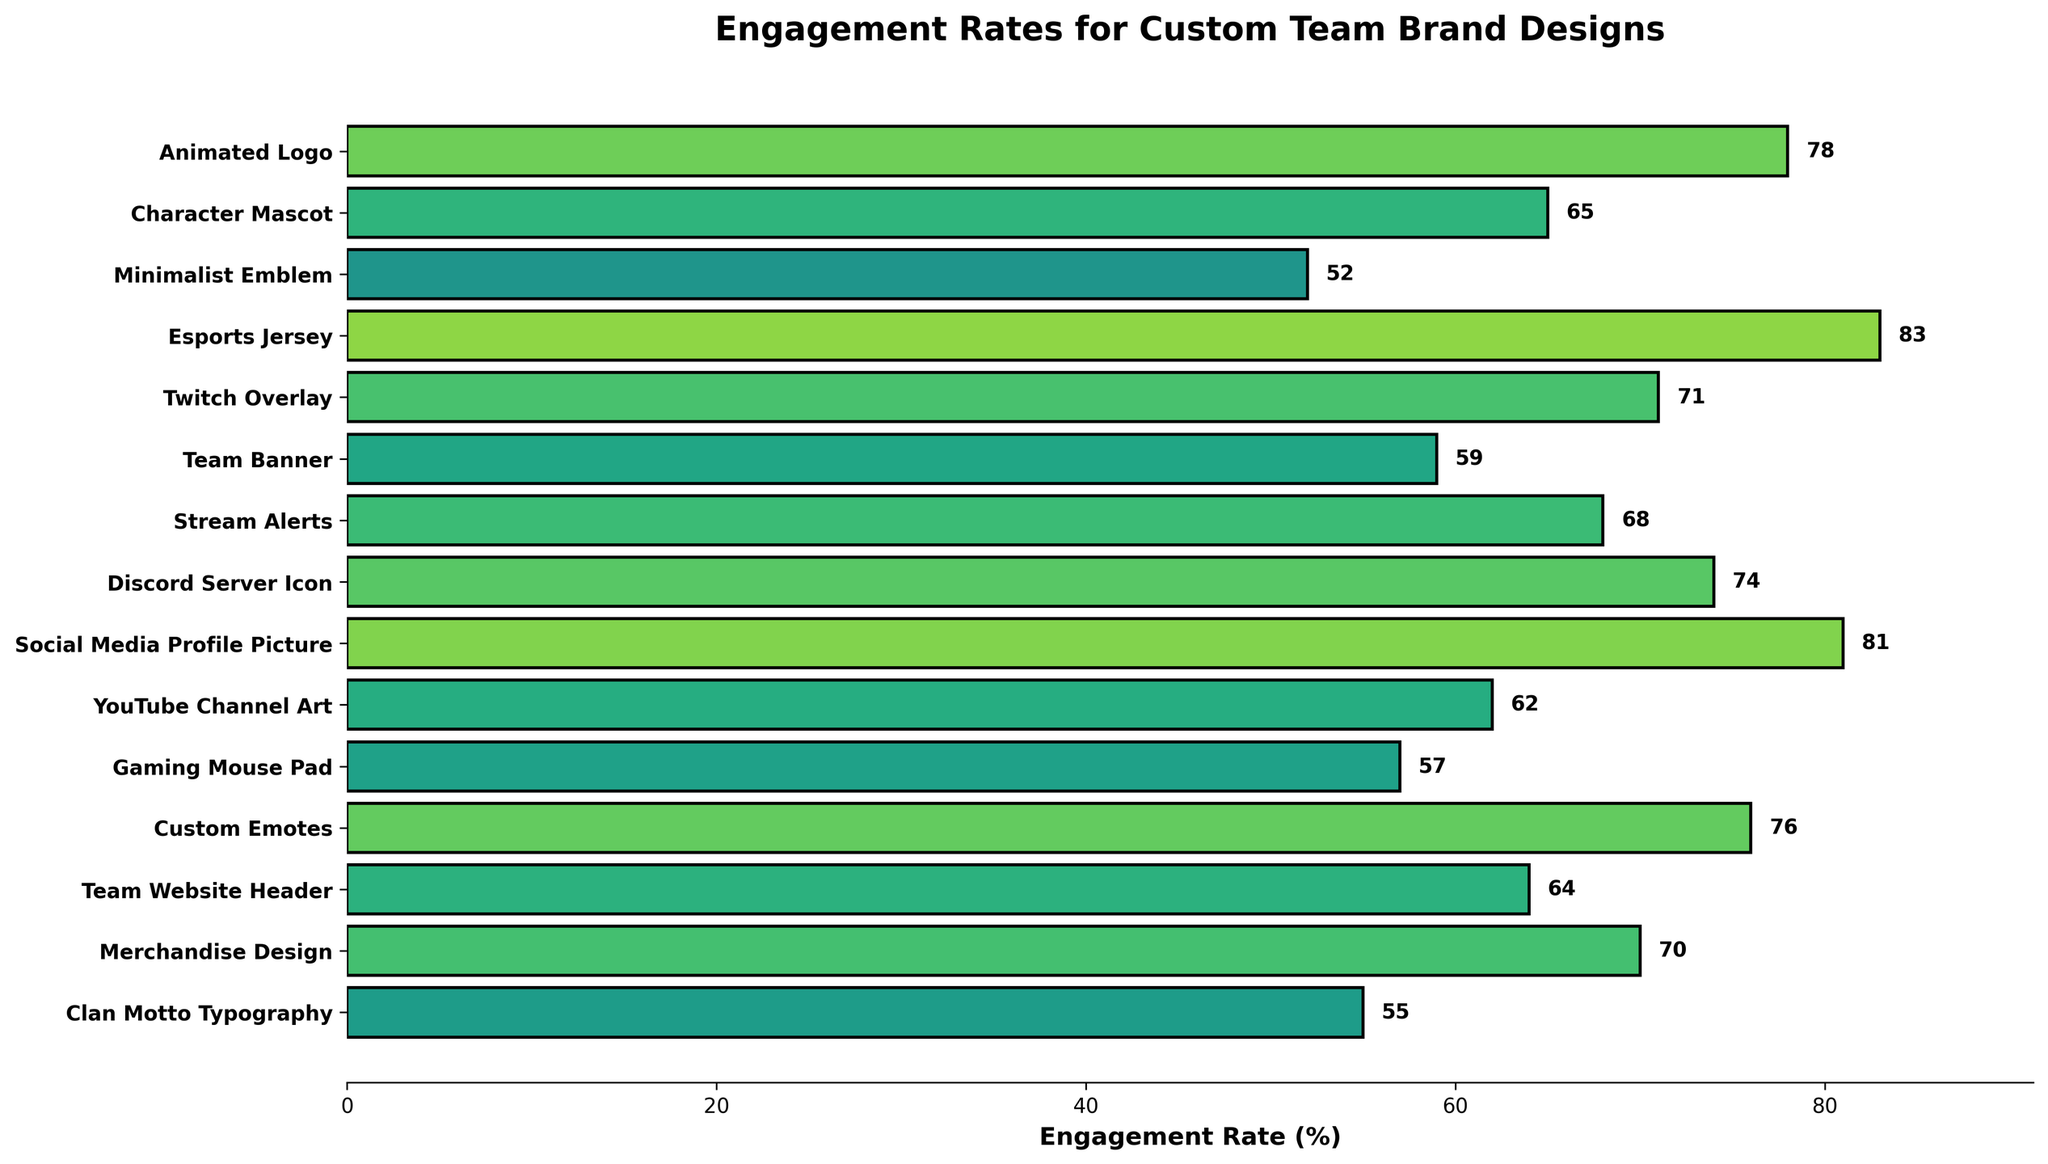Which design type has the highest engagement rate? The bar for Esports Jersey is the longest compared to others, reaching the highest engagement rate of 83%.
Answer: Esports Jersey Which engagement rate is lower: Custom Emotes or Social Media Profile Picture? The bar for Custom Emotes is 76%, while the bar for Social Media Profile Picture is 81%, indicating the latter has a higher engagement rate.
Answer: Custom Emotes What is the sum of the engagement rates for Character Mascot, Twitch Overlay, and Clan Motto Typography? Add the engagement rates of Character Mascot (65), Twitch Overlay (71), and Clan Motto Typography (55). The sum is 65 + 71 + 55 = 191%.
Answer: 191% What is the difference in engagement rate between the highest and the lowest design types? The highest engagement rate is for Esports Jersey (83%) and the lowest is for Minimalist Emblem (52%). The difference is 83 - 52 = 31%.
Answer: 31% How many design types have an engagement rate greater than 70%? Count the bars with engagement rates greater than 70%; they are Esports Jersey, Animated Logo, Social Media Profile Picture, Custom Emotes, Discord Server Icon, and Twitch Overlay, totaling 6.
Answer: 6 Which design type has an engagement rate closest to 60%? The bars closest to 60% are Team Banner (59%) and YouTube Channel Art (62%). Team Banner is closer.
Answer: Team Banner By how much does the Merchandise Design engagement rate exceed the Gaming Mouse Pad rate? The engagement rate for Merchandise Design is 70% and for Gaming Mouse Pad is 57%. The difference is 70 - 57 = 13%.
Answer: 13% What is the average engagement rate across all design types? Sum all engagement rates and divide by the number of design types. The sum is 78 + 65 + 52 + 83 + 71 + 59 + 68 + 74 + 81 + 62 + 57 + 76 + 64 + 70 + 55 = 1015. There are 15 design types, so the average is 1015 / 15 = 67.67%.
Answer: 67.67% Which design type's engagement rate falls between the engagement rates of Stream Alerts and YouTube Channel Art? The engagement rate for Stream Alerts is 68% and for YouTube Channel Art is 62%; Team Website Header has a rate of 64%, which falls in between.
Answer: Team Website Header 